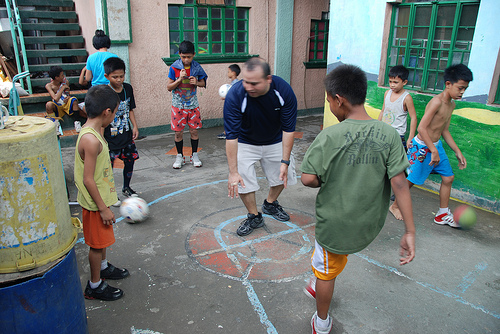<image>
Is there a man behind the house? No. The man is not behind the house. From this viewpoint, the man appears to be positioned elsewhere in the scene. Where is the ball in relation to the boy? Is it in front of the boy? No. The ball is not in front of the boy. The spatial positioning shows a different relationship between these objects. 